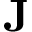Convert formula to latex. <formula><loc_0><loc_0><loc_500><loc_500>{ J }</formula> 